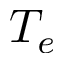<formula> <loc_0><loc_0><loc_500><loc_500>T _ { e }</formula> 